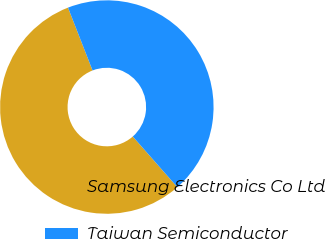Convert chart to OTSL. <chart><loc_0><loc_0><loc_500><loc_500><pie_chart><fcel>Samsung Electronics Co Ltd<fcel>Taiwan Semiconductor<nl><fcel>55.56%<fcel>44.44%<nl></chart> 